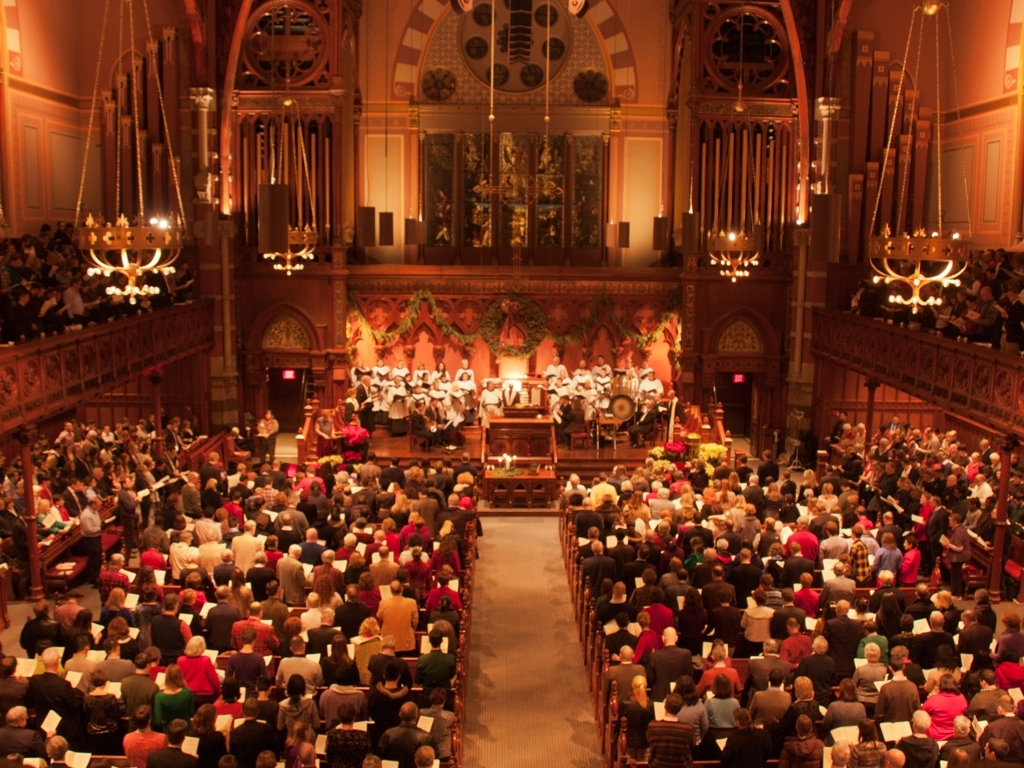What time of day does it appear to be? Given the artificial lighting inside and the lack of natural light coming through the arched windows, it seems the image was taken in the evening during an indoor event. The lighting gives the space a warm, welcoming ambiance. What emotions does the setting evoke? The setting exudes a sense of community and shared experience; the collective focus of the audience on the stage suggests engagement and enjoyment. The warm lighting and rich colors contribute to a feeling of coziness and tradition, likely making attendees feel connected and uplifted by the shared cultural or spiritual event. 